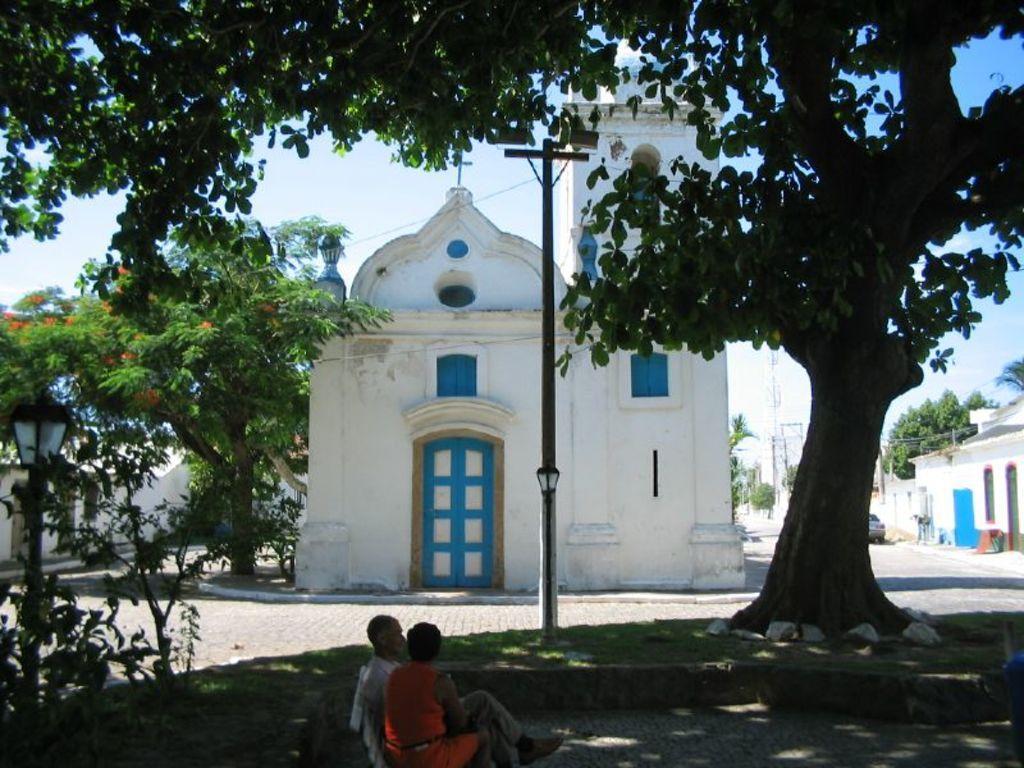How would you summarize this image in a sentence or two? I think this is a church with the window and a door. There are two people sitting. These are the trees. I can see a holy cross symbol, which is at the top of the building. These are the houses. This looks like a car on the road. I think this is a light pole. 